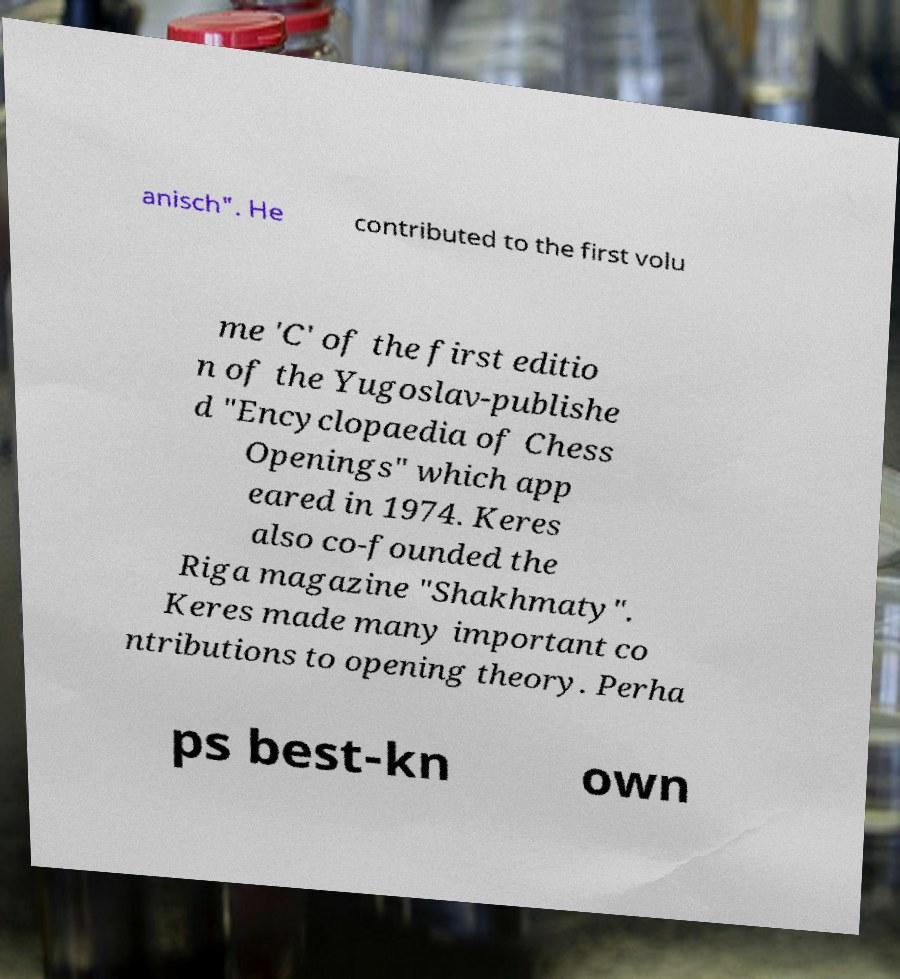Please read and relay the text visible in this image. What does it say? anisch". He contributed to the first volu me 'C' of the first editio n of the Yugoslav-publishe d "Encyclopaedia of Chess Openings" which app eared in 1974. Keres also co-founded the Riga magazine "Shakhmaty". Keres made many important co ntributions to opening theory. Perha ps best-kn own 